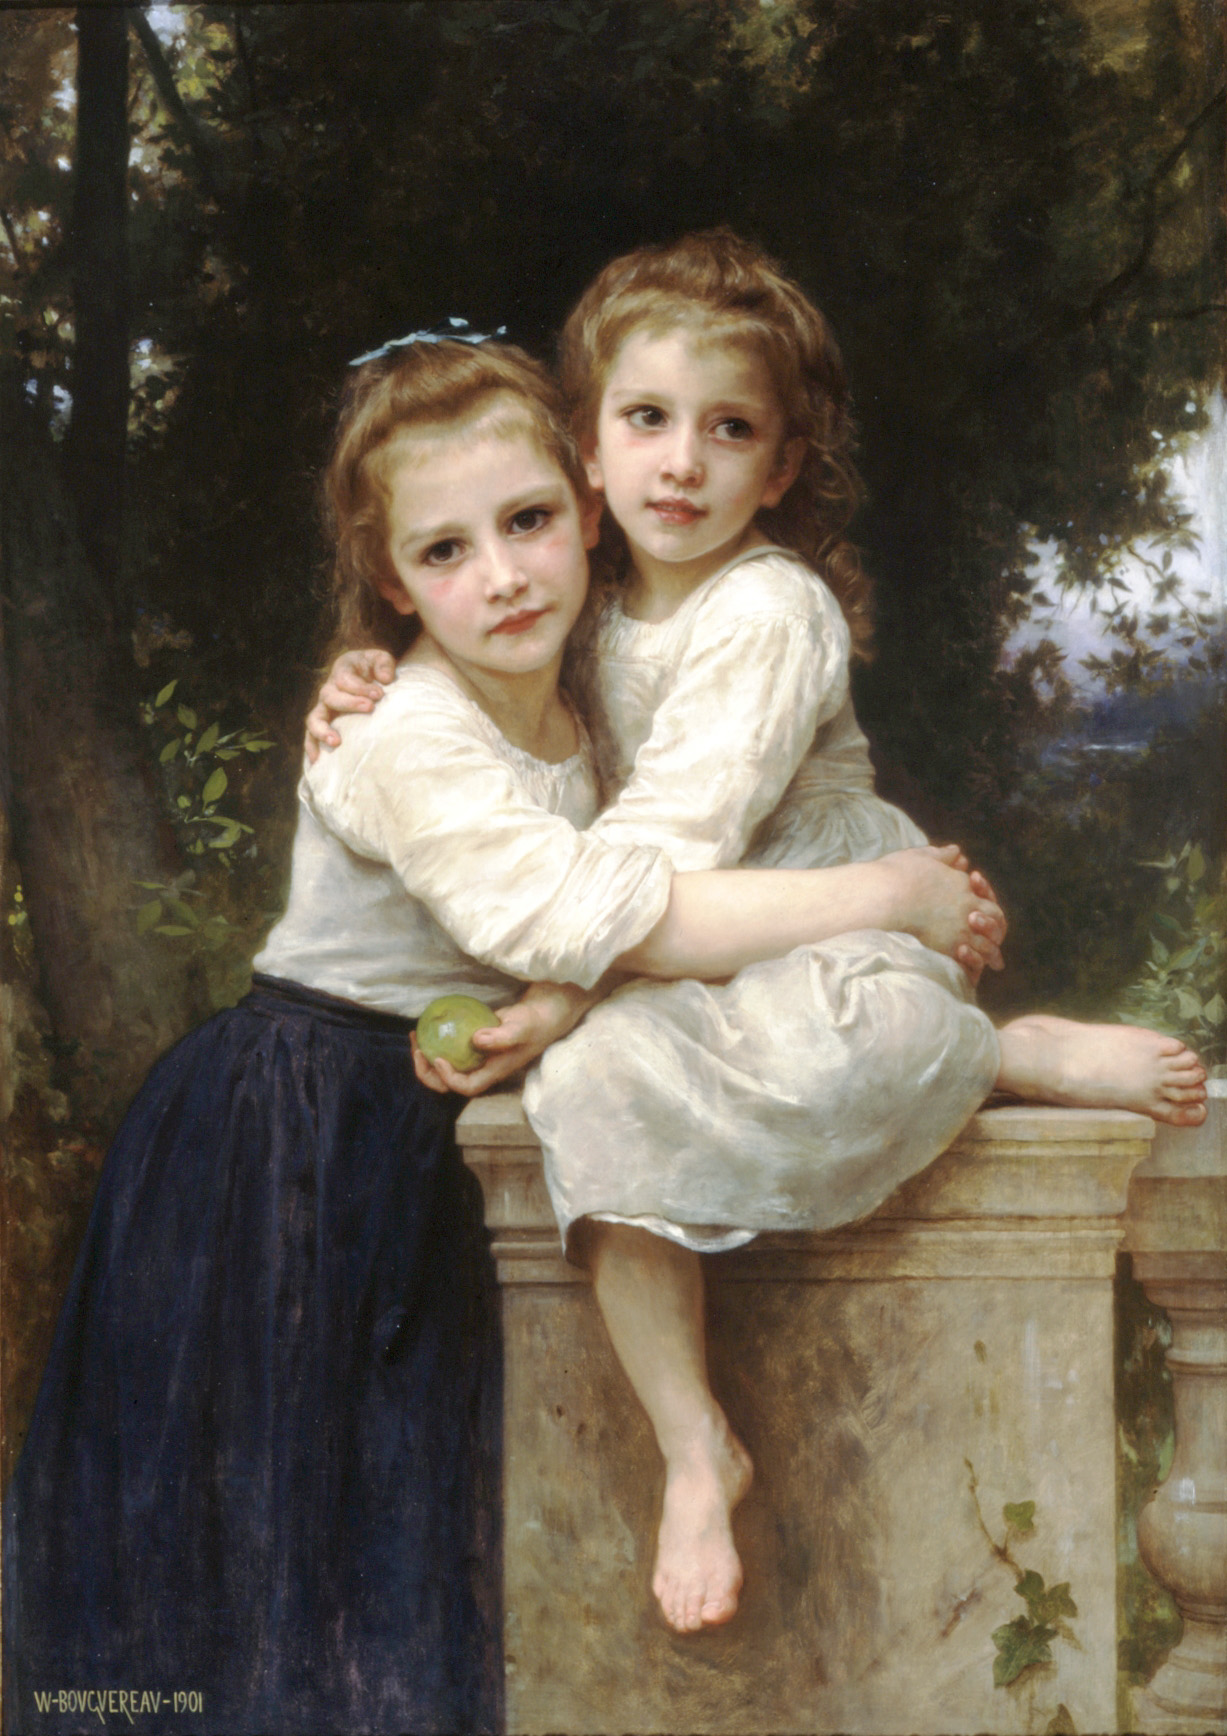Imagine the girls are characters in a fantastical tale, what kind of adventure could they be on? In a magical realm where the boundaries between reality and dreams fade, Emily and Clara stumbled upon an enchanted garden, its entrance concealed by vines of shimmering emerald. As they stepped into this mystical world, the stone balustrade transformed into the threshold of a fantastical castle. The apple in Emily’s hand revealed itself as a key, unlocking doors to realms filled with mythical creatures and grand adventures. Their journey led them through forests of whispering trees, across crystalline streams, and into grand halls where they encountered majestic, talking animals and wise, benevolent sorcerers. Each challenge they faced—whether deciphering ancient, magical runes or uniting warring kingdoms—brought them closer, their sisterly bond their greatest strength. The lush garden backdrop of their adventure was a safe haven, a place they could always return to, where their journey had begun and where the warmth of home awaited them. 